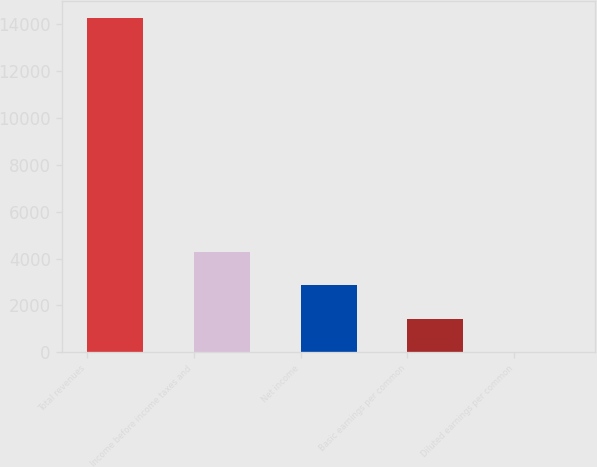<chart> <loc_0><loc_0><loc_500><loc_500><bar_chart><fcel>Total revenues<fcel>Income before income taxes and<fcel>Net income<fcel>Basic earnings per common<fcel>Diluted earnings per common<nl><fcel>14279<fcel>4286.18<fcel>2858.63<fcel>1431.08<fcel>3.53<nl></chart> 